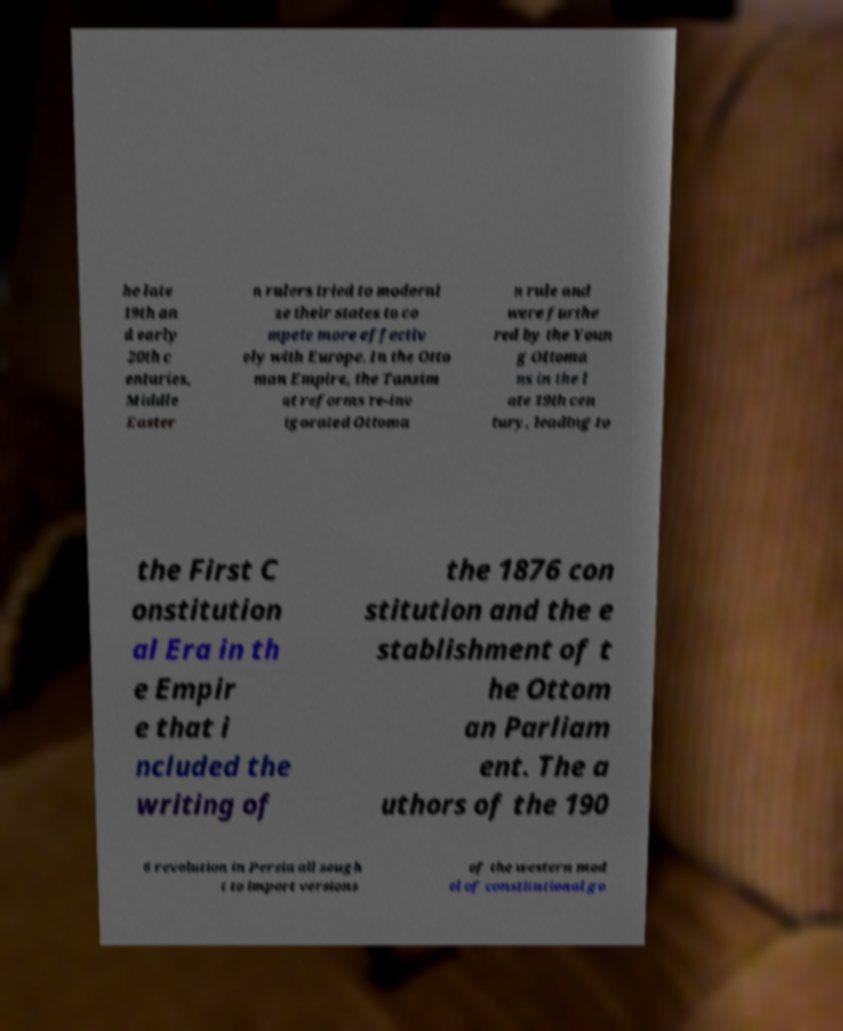For documentation purposes, I need the text within this image transcribed. Could you provide that? he late 19th an d early 20th c enturies, Middle Easter n rulers tried to moderni ze their states to co mpete more effectiv ely with Europe. In the Otto man Empire, the Tanzim at reforms re-inv igorated Ottoma n rule and were furthe red by the Youn g Ottoma ns in the l ate 19th cen tury, leading to the First C onstitution al Era in th e Empir e that i ncluded the writing of the 1876 con stitution and the e stablishment of t he Ottom an Parliam ent. The a uthors of the 190 6 revolution in Persia all sough t to import versions of the western mod el of constitutional go 